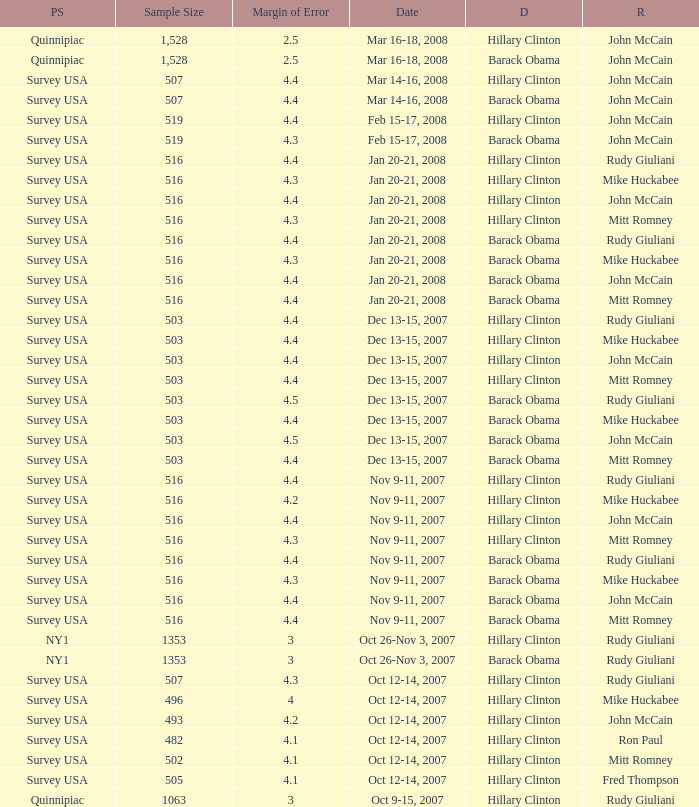What is the sample size of the poll taken on Dec 13-15, 2007 that had a margin of error of more than 4 and resulted with Republican Mike Huckabee? 503.0. 